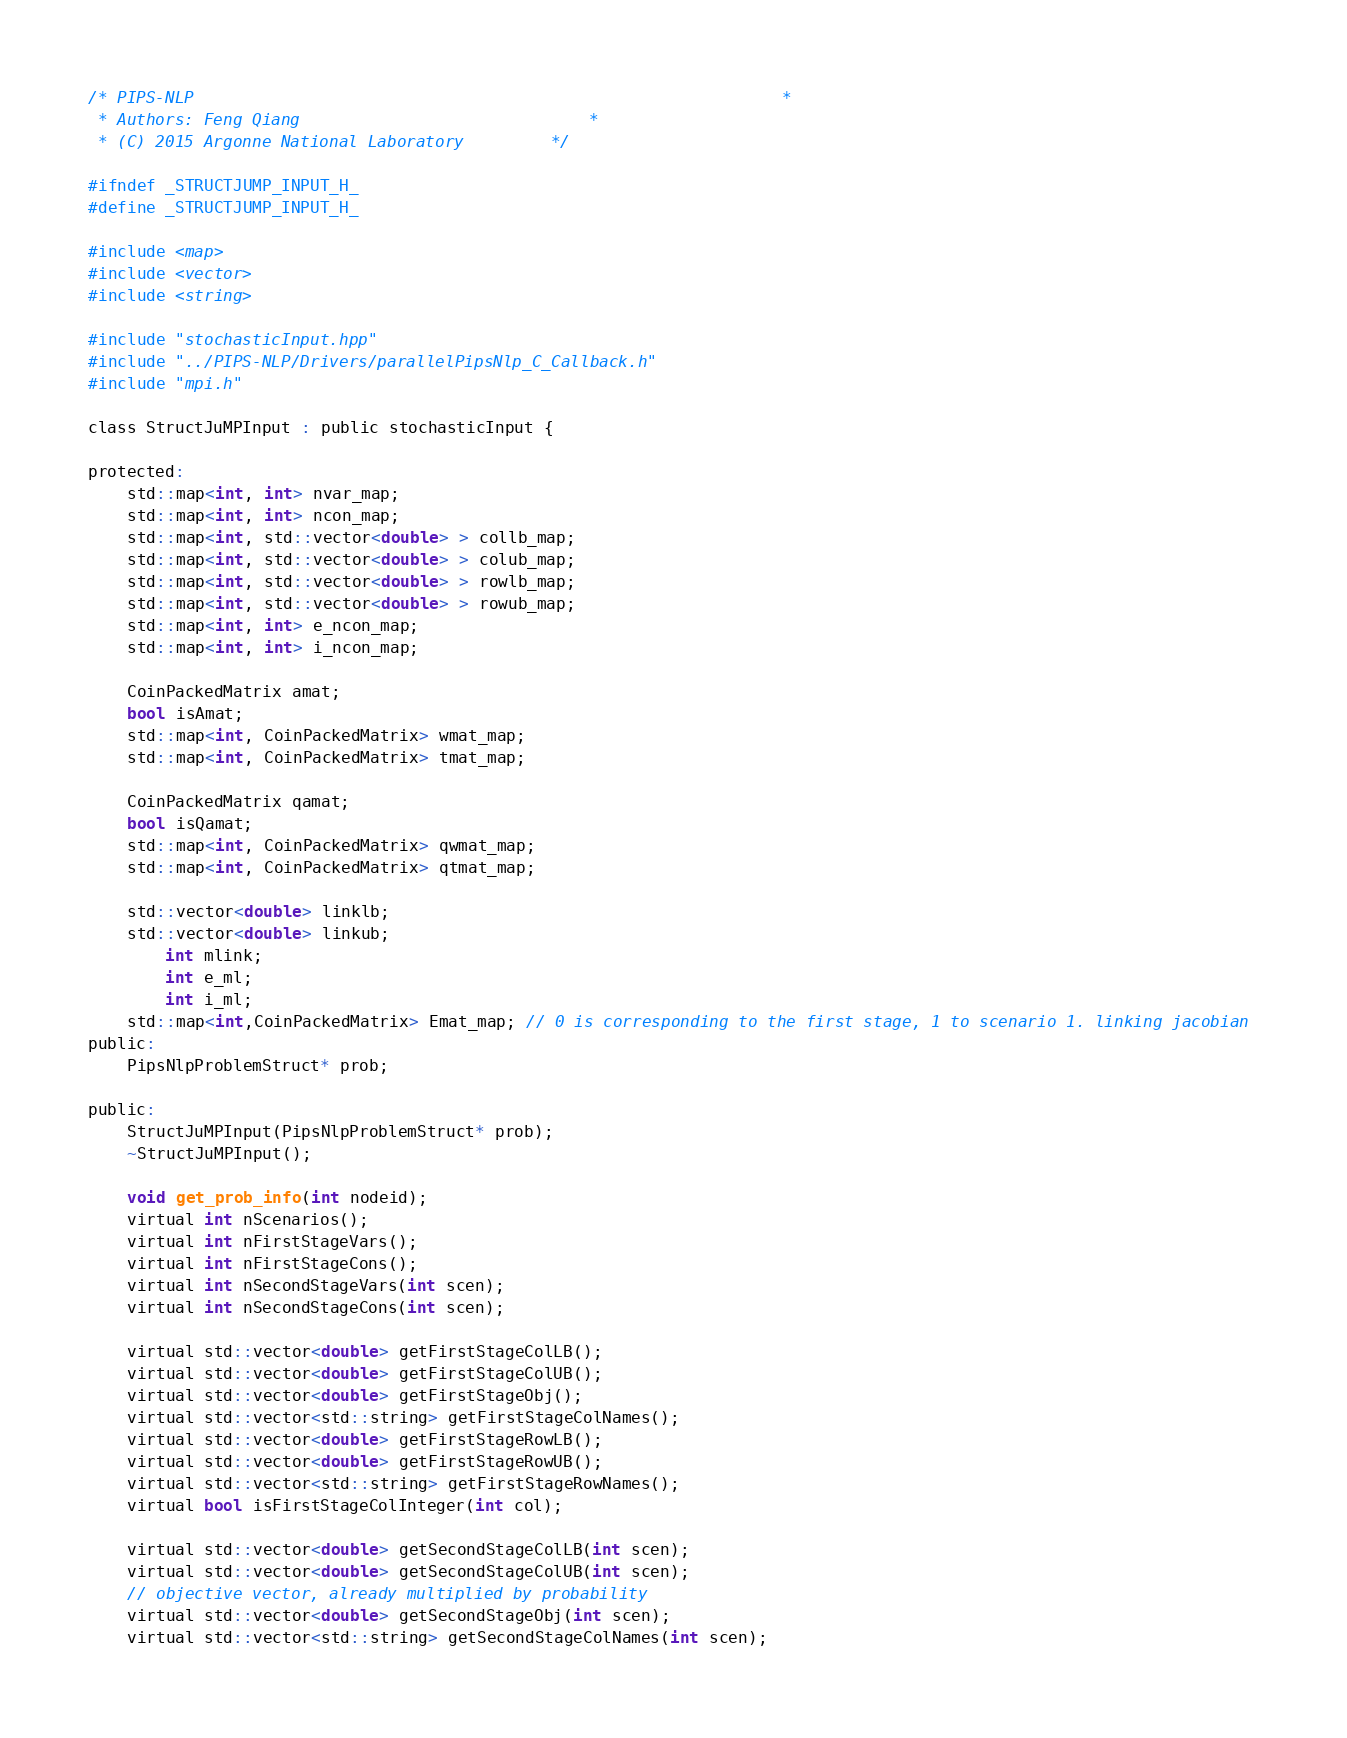Convert code to text. <code><loc_0><loc_0><loc_500><loc_500><_C_>/* PIPS-NLP                                                         	*
 * Authors: Feng Qiang                      		*
 * (C) 2015 Argonne National Laboratory			*/

#ifndef _STRUCTJUMP_INPUT_H_
#define _STRUCTJUMP_INPUT_H_

#include <map>
#include <vector>
#include <string>

#include "stochasticInput.hpp"
#include "../PIPS-NLP/Drivers/parallelPipsNlp_C_Callback.h"
#include "mpi.h"

class StructJuMPInput : public stochasticInput {

protected:
	std::map<int, int> nvar_map;
	std::map<int, int> ncon_map;
	std::map<int, std::vector<double> > collb_map;
	std::map<int, std::vector<double> > colub_map;
	std::map<int, std::vector<double> > rowlb_map;
	std::map<int, std::vector<double> > rowub_map;
	std::map<int, int> e_ncon_map;
	std::map<int, int> i_ncon_map;

	CoinPackedMatrix amat;
	bool isAmat;
	std::map<int, CoinPackedMatrix> wmat_map;
	std::map<int, CoinPackedMatrix> tmat_map;

	CoinPackedMatrix qamat;
	bool isQamat;
	std::map<int, CoinPackedMatrix> qwmat_map;
	std::map<int, CoinPackedMatrix> qtmat_map;

	std::vector<double> linklb;
	std::vector<double> linkub;
        int mlink;
        int e_ml;
        int i_ml;
	std::map<int,CoinPackedMatrix> Emat_map; // 0 is corresponding to the first stage, 1 to scenario 1. linking jacobian 
public:
	PipsNlpProblemStruct* prob;

public:
	StructJuMPInput(PipsNlpProblemStruct* prob);
	~StructJuMPInput();

	void get_prob_info(int nodeid);
	virtual int nScenarios();
	virtual int nFirstStageVars();
	virtual int nFirstStageCons();
	virtual int nSecondStageVars(int scen);
	virtual int nSecondStageCons(int scen);

	virtual std::vector<double> getFirstStageColLB();
	virtual std::vector<double> getFirstStageColUB();
	virtual std::vector<double> getFirstStageObj();
	virtual std::vector<std::string> getFirstStageColNames();
	virtual std::vector<double> getFirstStageRowLB();
	virtual std::vector<double> getFirstStageRowUB();
	virtual std::vector<std::string> getFirstStageRowNames();
	virtual bool isFirstStageColInteger(int col);

	virtual std::vector<double> getSecondStageColLB(int scen);
	virtual std::vector<double> getSecondStageColUB(int scen);
	// objective vector, already multiplied by probability
	virtual std::vector<double> getSecondStageObj(int scen);
	virtual std::vector<std::string> getSecondStageColNames(int scen);</code> 